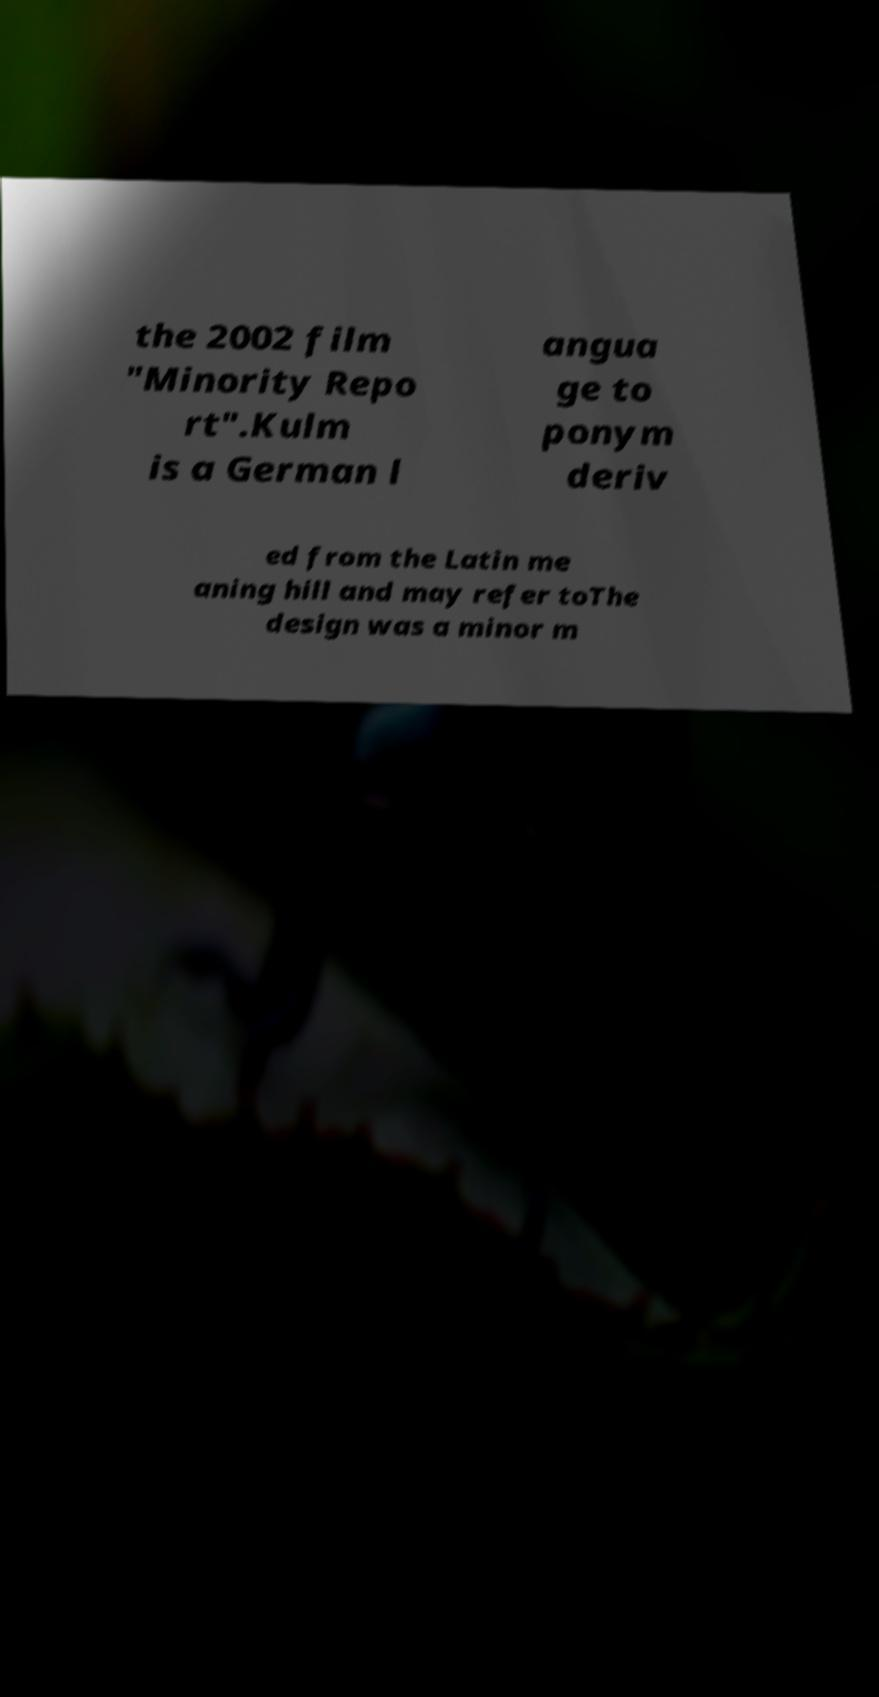Could you assist in decoding the text presented in this image and type it out clearly? the 2002 film "Minority Repo rt".Kulm is a German l angua ge to ponym deriv ed from the Latin me aning hill and may refer toThe design was a minor m 